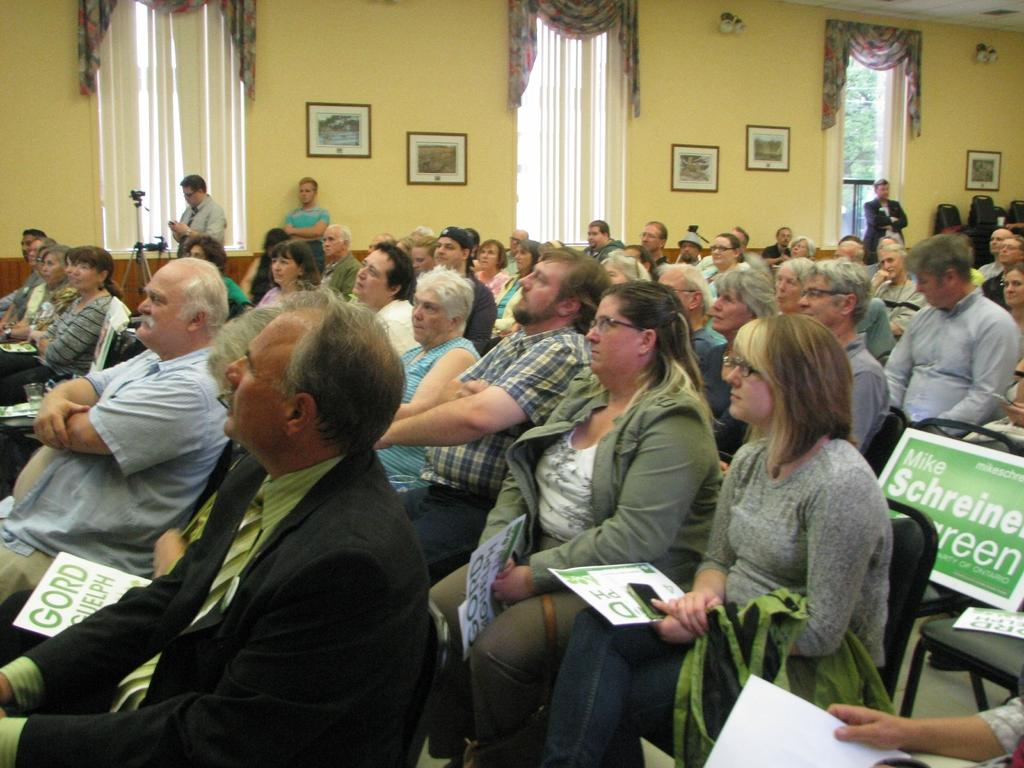What is the main subject of the image? The main subject of the image is a group of people. What are the people in the image doing? The people are sitting on chairs in the image. What can be seen at the top of the image? There are curtains at the top of the image. What is hanging on the wall in the image? There are photo frames on the wall in the image. How many roses are on the table in the image? There are no roses present in the image. Is there a tub visible in the image? No, there is no tub visible in the image. 